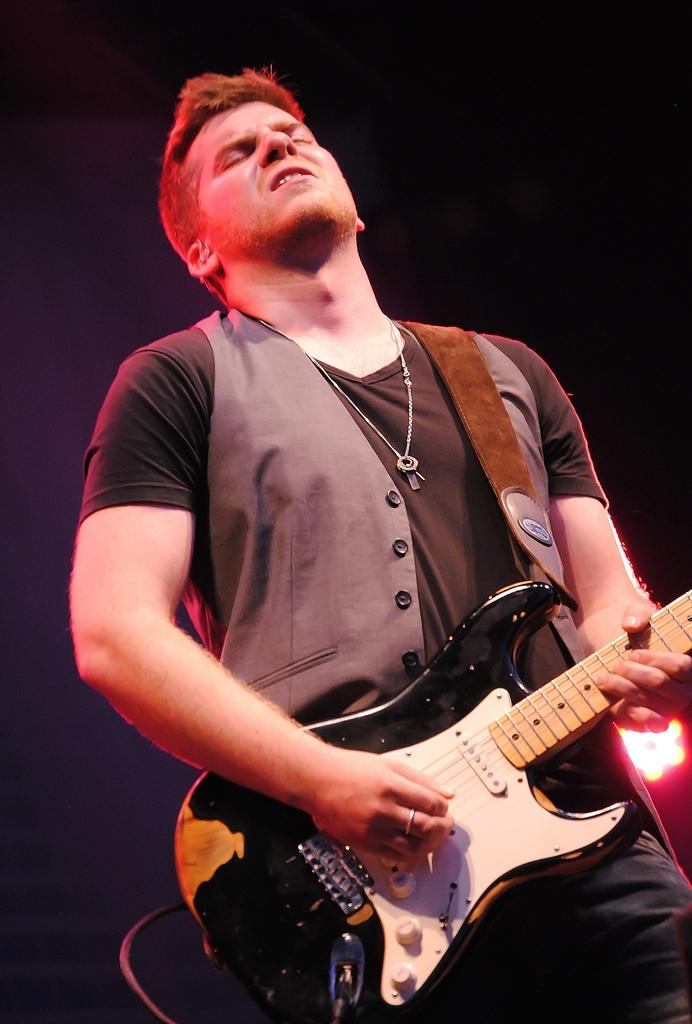What is the main subject of the image? The main subject of the image is a man. What is the man doing in the image? The man is standing in the image. What object is the man holding in the image? The man is holding a guitar in his hand. What year is depicted in the image? There is no specific year depicted in the image; it is a photograph of a man holding a guitar. How many rays of sunlight can be seen in the image? There are no rays of sunlight visible in the image; it is focused on the man and his guitar. 